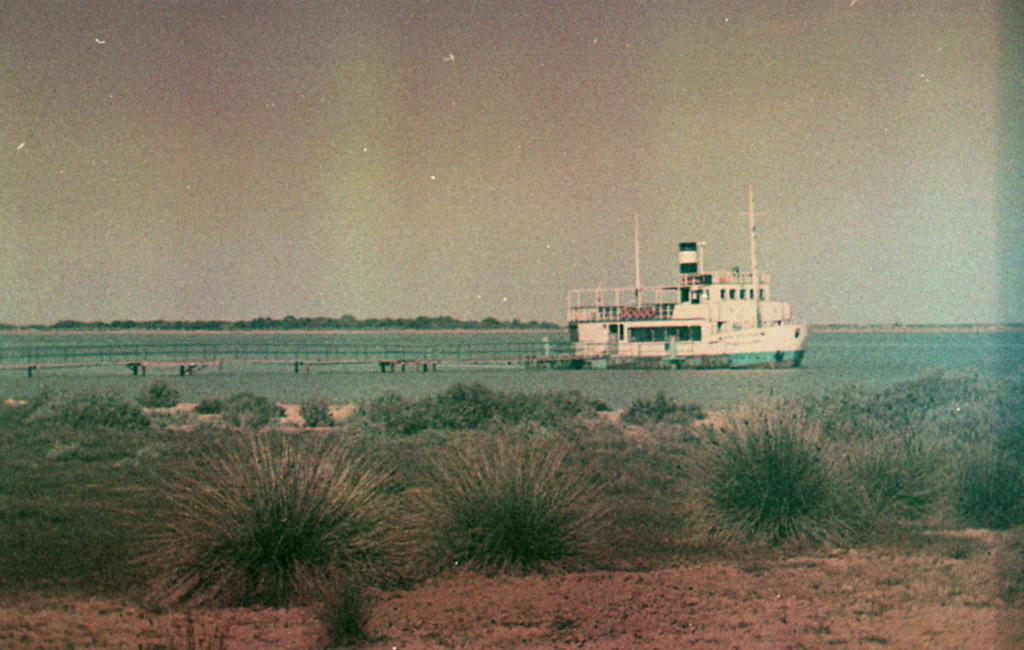What is located in the front of the image? There are plants in the front of the image. What is the main subject in the center of the image? There is a ship in the center of the image. What is the ship situated on? The ship is on water. What can be seen in the background of the image? There are trees in the background of the image. Can you tell me how many fowls are on the ship in the image? There is no mention of fowls in the image; it features a ship on water with plants in the front and trees in the background. How does the person in the image touch the plants? There is no person present in the image, so it is not possible to determine how they might touch the plants. 